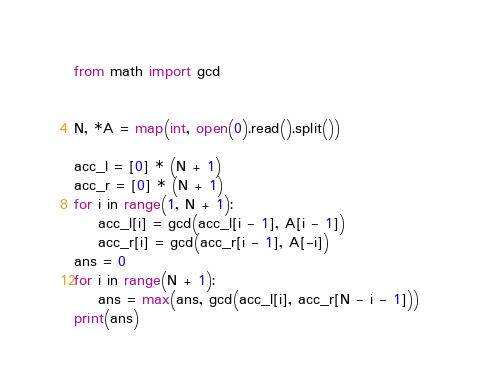Convert code to text. <code><loc_0><loc_0><loc_500><loc_500><_Python_>from math import gcd


N, *A = map(int, open(0).read().split())

acc_l = [0] * (N + 1)
acc_r = [0] * (N + 1)
for i in range(1, N + 1):
    acc_l[i] = gcd(acc_l[i - 1], A[i - 1])
    acc_r[i] = gcd(acc_r[i - 1], A[-i])
ans = 0
for i in range(N + 1):
    ans = max(ans, gcd(acc_l[i], acc_r[N - i - 1]))
print(ans)
</code> 